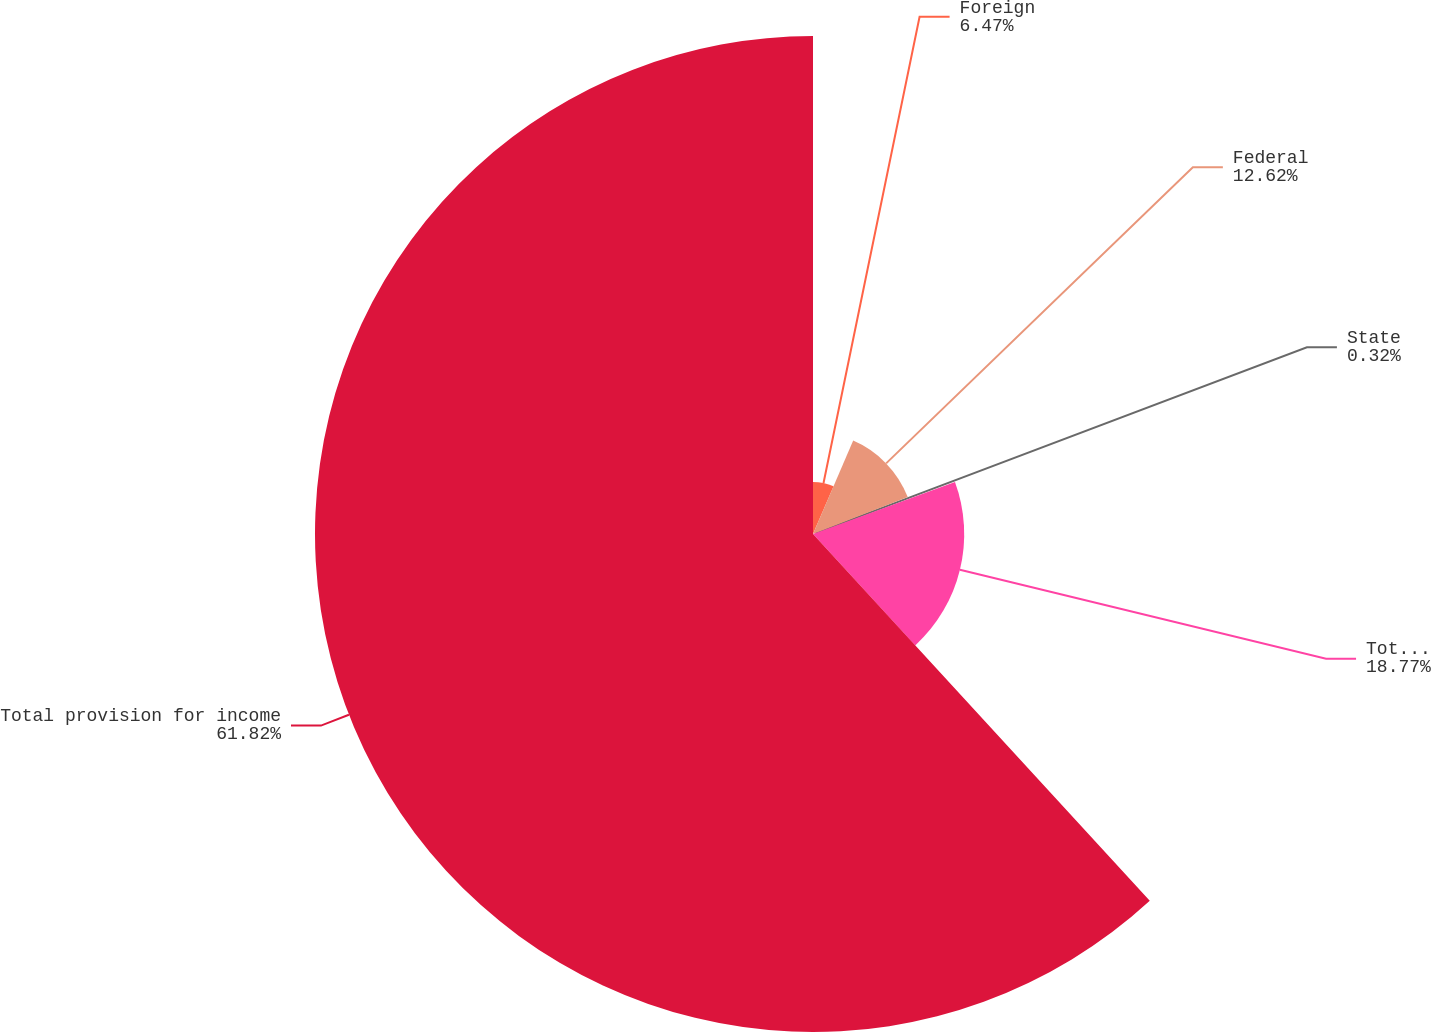Convert chart. <chart><loc_0><loc_0><loc_500><loc_500><pie_chart><fcel>Foreign<fcel>Federal<fcel>State<fcel>Total deferred<fcel>Total provision for income<nl><fcel>6.47%<fcel>12.62%<fcel>0.32%<fcel>18.77%<fcel>61.82%<nl></chart> 